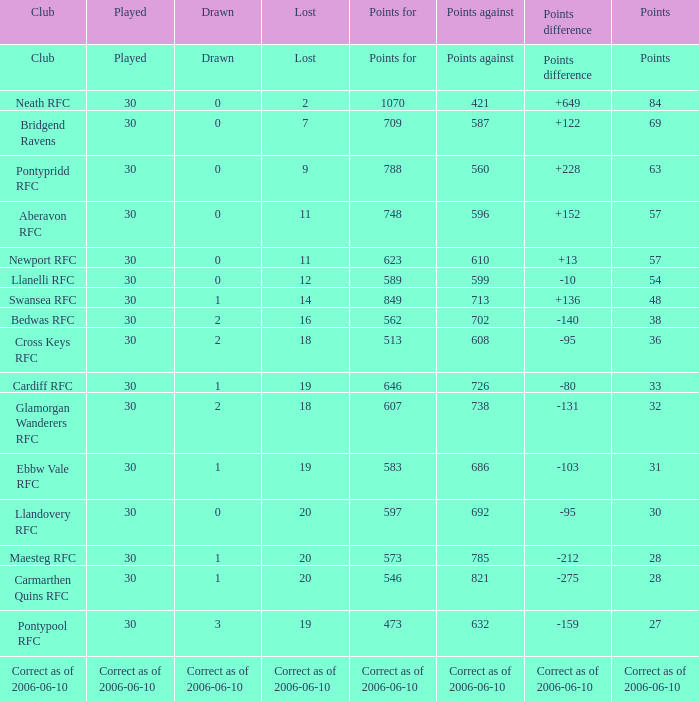When "points against" equals 686, what is depicted? 1.0. 